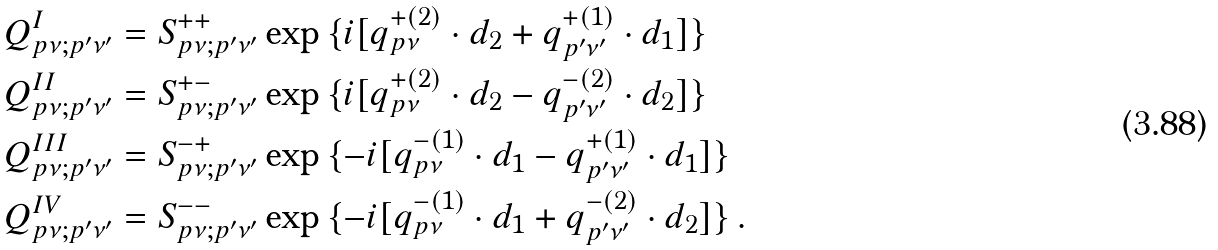<formula> <loc_0><loc_0><loc_500><loc_500>& Q _ { p \nu ; p ^ { \prime } \nu ^ { \prime } } ^ { I } = S _ { p \nu ; p ^ { \prime } \nu ^ { \prime } } ^ { + + } \exp { \{ i [ q _ { p \nu } ^ { + ( 2 ) } \cdot d _ { 2 } + q _ { p ^ { \prime } \nu ^ { \prime } } ^ { + ( 1 ) } \cdot d _ { 1 } ] \} } \\ & Q _ { p \nu ; p ^ { \prime } \nu ^ { \prime } } ^ { I I } = S _ { p \nu ; p ^ { \prime } \nu ^ { \prime } } ^ { + - } \exp { \{ i [ q _ { p \nu } ^ { + ( 2 ) } \cdot d _ { 2 } - q _ { p ^ { \prime } \nu ^ { \prime } } ^ { - ( 2 ) } \cdot d _ { 2 } ] \} } \\ & Q _ { p \nu ; p ^ { \prime } \nu ^ { \prime } } ^ { I I I } = S _ { p \nu ; p ^ { \prime } \nu ^ { \prime } } ^ { - + } \exp { \{ - i [ q _ { p \nu } ^ { - ( 1 ) } \cdot d _ { 1 } - q _ { p ^ { \prime } \nu ^ { \prime } } ^ { + ( 1 ) } \cdot d _ { 1 } ] \} } \\ & Q _ { p \nu ; p ^ { \prime } \nu ^ { \prime } } ^ { I V } = S _ { p \nu ; p ^ { \prime } \nu ^ { \prime } } ^ { - - } \exp { \{ - i [ q _ { p \nu } ^ { - ( 1 ) } \cdot d _ { 1 } + q _ { p ^ { \prime } \nu ^ { \prime } } ^ { - ( 2 ) } \cdot d _ { 2 } ] \} } \, .</formula> 